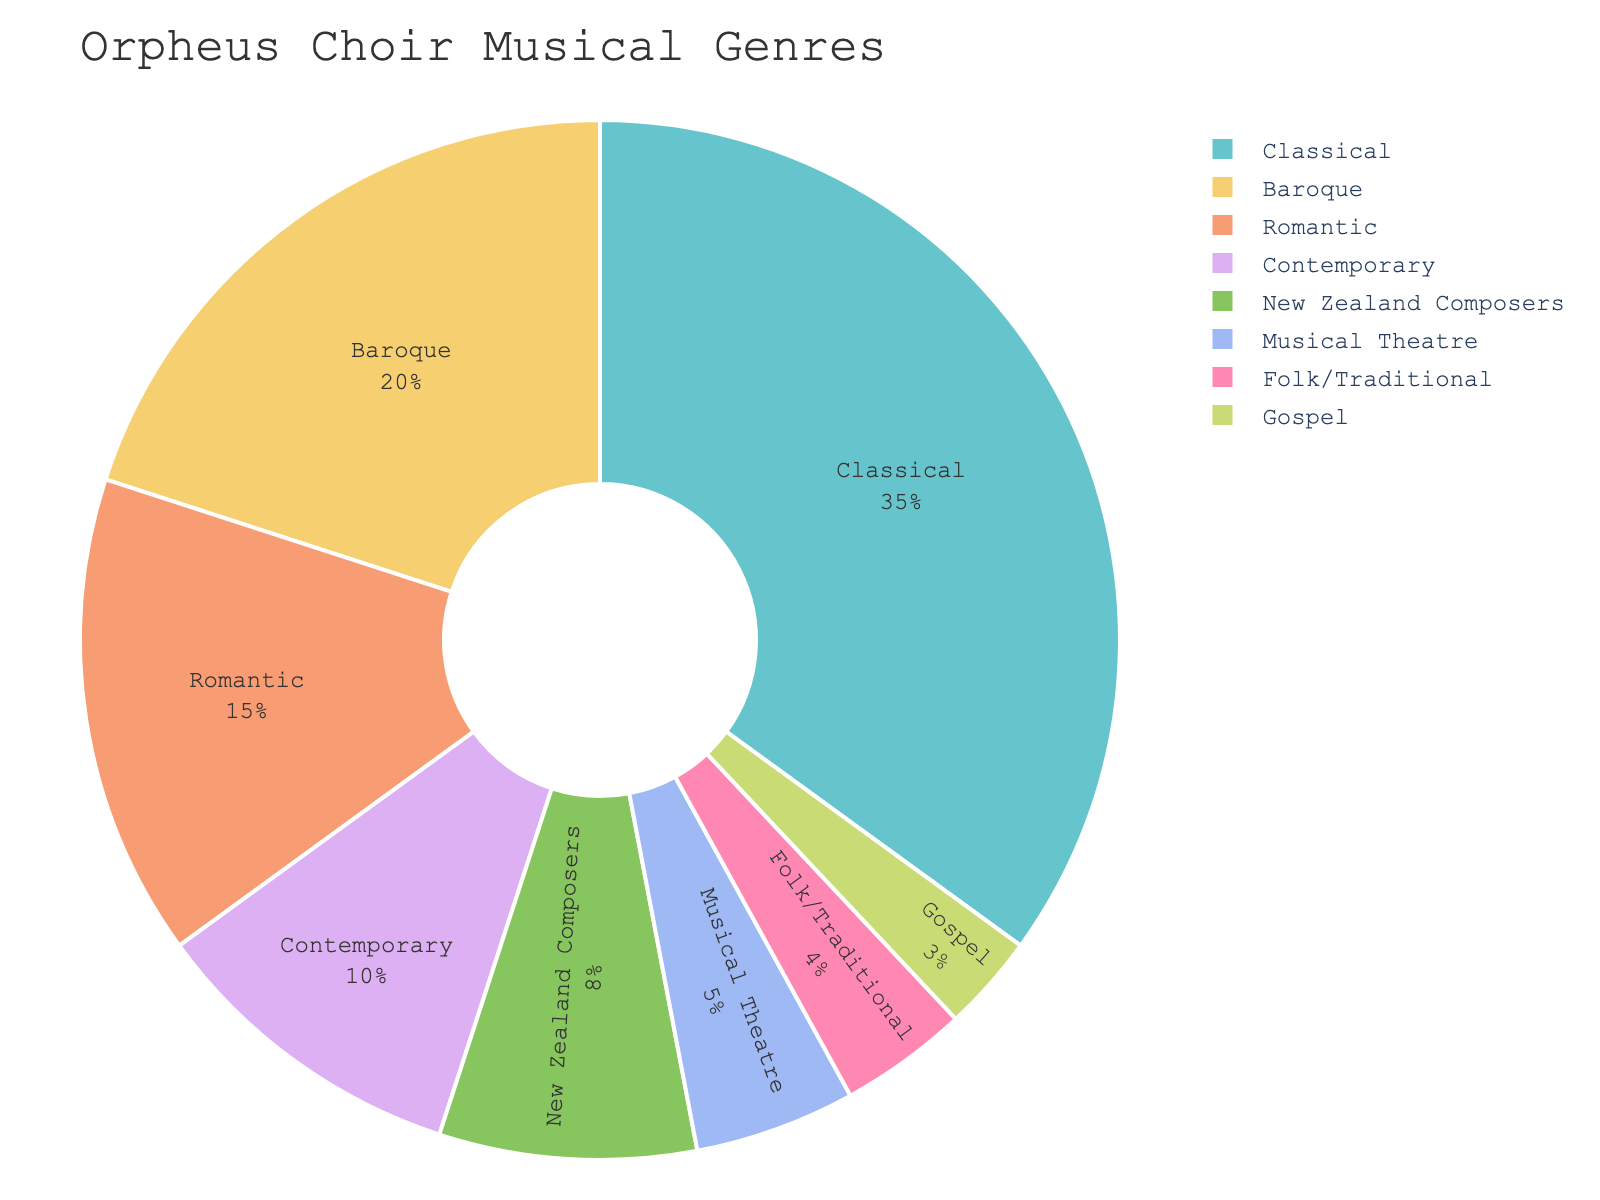what genre has the highest percentage in the pie chart? The pie chart shows the breakdown of genres by percentage. The Classical genre has the highest percentage, marked at 35%.
Answer: Classical which genre has the lowest percentage? The pie chart indicates that Gospel has the lowest percentage of 3%.
Answer: Gospel how many genres have a percentage greater than 10%? By examining the pie chart, we see the genres with percentages greater than 10% are Classical (35%), Baroque (20%), and Romantic (15%). There are 3 such genres.
Answer: 3 what is the sum of the percentages for Contemporary and New Zealand Composers? From the pie chart, we find Contemporary at 10% and New Zealand Composers at 8%. Adding these two gives 10% + 8% = 18%.
Answer: 18% are there more genres with a percentage less than or equal to 10% or greater than 10%? We observe the genres: less than or equal to 10% (Contemporary, New Zealand Composers, Musical Theatre, Folk/Traditional, Gospel) and greater than 10% (Classical, Baroque, Romantic). There are 5 genres ≤ 10% and 3 genres > 10%, so more genres are ≤ 10%.
Answer: less than or equal to 10% what is the difference in percentage between Baroque and Romantic genres? Baroque is shown as 20% and Romantic as 15%. The difference is 20% - 15% = 5%.
Answer: 5% which genre represents more percentage, Folk/Traditional or Musical Theatre? From the pie chart, Folk/Traditional is 4% and Musical Theatre is 5%. Therefore, Musical Theatre has the higher percentage.
Answer: Musical Theatre what percentage of the chart do the genres with the smallest three percentages cover? The three smallest percentages are Gospel (3%), Folk/Traditional (4%), and Musical Theatre (5%). Summing these gives 3% + 4% + 5% = 12%.
Answer: 12% if the genres Baroque and Classical were combined, what would their total percentage be? Adding the percentages of Baroque (20%) and Classical (35%), we get 20% + 35% = 55%.
Answer: 55% what is the average percentage of all the genres listed? Adding all percentages (35% + 20% + 15% + 10% + 8% + 5% + 4% + 3%) gives 100%. With 8 genres, the average is 100% / 8 = 12.5%.
Answer: 12.5% 